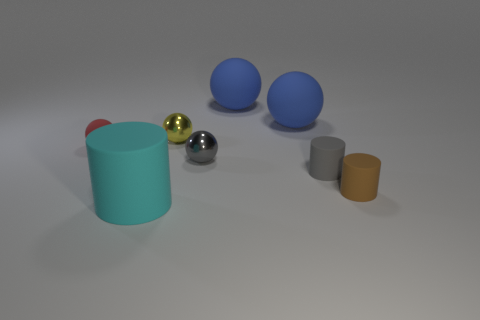Subtract all gray metal balls. How many balls are left? 4 Subtract all brown cylinders. How many blue spheres are left? 2 Subtract all gray balls. How many balls are left? 4 Add 1 small yellow objects. How many objects exist? 9 Subtract all balls. How many objects are left? 3 Subtract all yellow spheres. Subtract all purple cylinders. How many spheres are left? 4 Subtract all tiny yellow shiny spheres. Subtract all balls. How many objects are left? 2 Add 6 gray spheres. How many gray spheres are left? 7 Add 2 blue cylinders. How many blue cylinders exist? 2 Subtract 0 yellow cylinders. How many objects are left? 8 